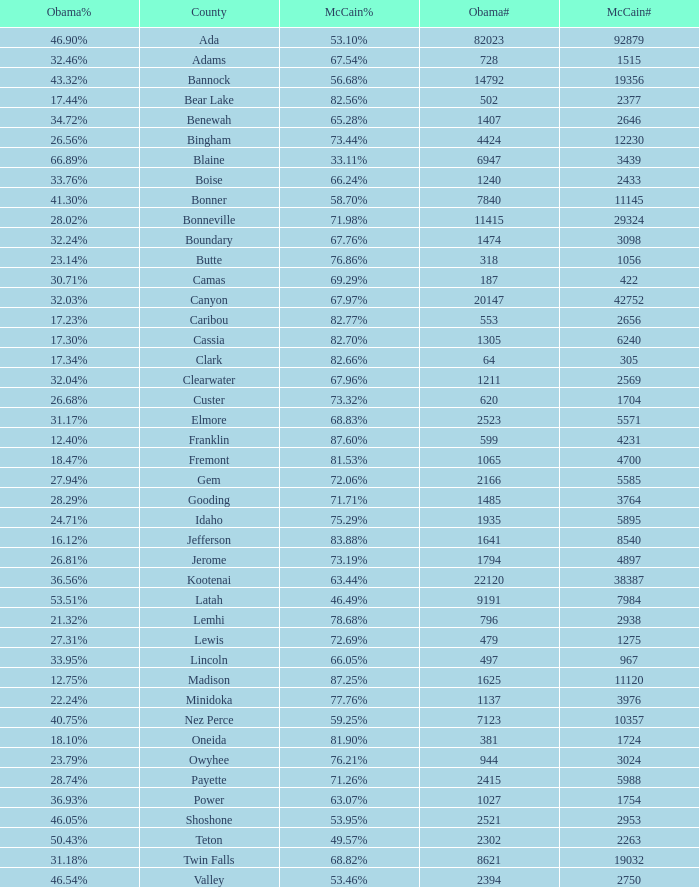What is the maximum McCain population turnout number? 92879.0. 